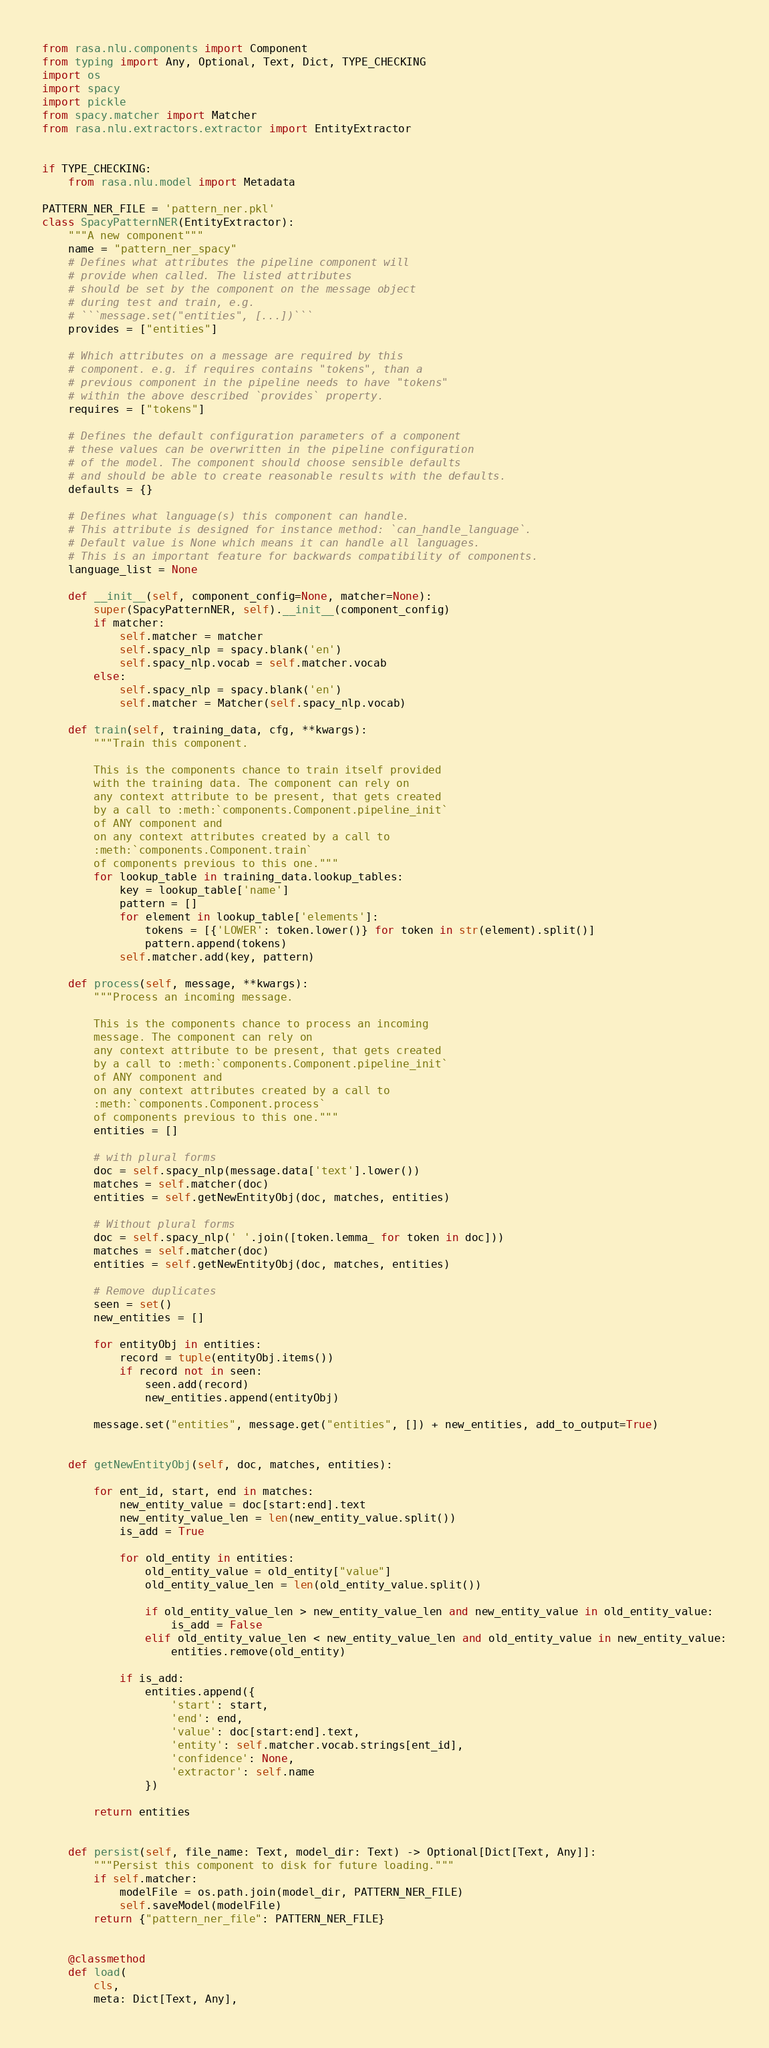<code> <loc_0><loc_0><loc_500><loc_500><_Python_>from rasa.nlu.components import Component
from typing import Any, Optional, Text, Dict, TYPE_CHECKING
import os
import spacy
import pickle
from spacy.matcher import Matcher
from rasa.nlu.extractors.extractor import EntityExtractor


if TYPE_CHECKING:
    from rasa.nlu.model import Metadata

PATTERN_NER_FILE = 'pattern_ner.pkl'
class SpacyPatternNER(EntityExtractor):
    """A new component"""
    name = "pattern_ner_spacy"
    # Defines what attributes the pipeline component will
    # provide when called. The listed attributes
    # should be set by the component on the message object
    # during test and train, e.g.
    # ```message.set("entities", [...])```
    provides = ["entities"]

    # Which attributes on a message are required by this
    # component. e.g. if requires contains "tokens", than a
    # previous component in the pipeline needs to have "tokens"
    # within the above described `provides` property.
    requires = ["tokens"]

    # Defines the default configuration parameters of a component
    # these values can be overwritten in the pipeline configuration
    # of the model. The component should choose sensible defaults
    # and should be able to create reasonable results with the defaults.
    defaults = {}

    # Defines what language(s) this component can handle.
    # This attribute is designed for instance method: `can_handle_language`.
    # Default value is None which means it can handle all languages.
    # This is an important feature for backwards compatibility of components.
    language_list = None

    def __init__(self, component_config=None, matcher=None):
        super(SpacyPatternNER, self).__init__(component_config)
        if matcher:
            self.matcher = matcher
            self.spacy_nlp = spacy.blank('en')
            self.spacy_nlp.vocab = self.matcher.vocab
        else:
            self.spacy_nlp = spacy.blank('en')
            self.matcher = Matcher(self.spacy_nlp.vocab)

    def train(self, training_data, cfg, **kwargs):
        """Train this component.

        This is the components chance to train itself provided
        with the training data. The component can rely on
        any context attribute to be present, that gets created
        by a call to :meth:`components.Component.pipeline_init`
        of ANY component and
        on any context attributes created by a call to
        :meth:`components.Component.train`
        of components previous to this one."""
        for lookup_table in training_data.lookup_tables:
            key = lookup_table['name']
            pattern = []
            for element in lookup_table['elements']:
                tokens = [{'LOWER': token.lower()} for token in str(element).split()]
                pattern.append(tokens)
            self.matcher.add(key, pattern)

    def process(self, message, **kwargs):
        """Process an incoming message.

        This is the components chance to process an incoming
        message. The component can rely on
        any context attribute to be present, that gets created
        by a call to :meth:`components.Component.pipeline_init`
        of ANY component and
        on any context attributes created by a call to
        :meth:`components.Component.process`
        of components previous to this one."""
        entities = []

        # with plural forms
        doc = self.spacy_nlp(message.data['text'].lower())
        matches = self.matcher(doc)
        entities = self.getNewEntityObj(doc, matches, entities)

        # Without plural forms
        doc = self.spacy_nlp(' '.join([token.lemma_ for token in doc]))
        matches = self.matcher(doc)
        entities = self.getNewEntityObj(doc, matches, entities)

        # Remove duplicates
        seen = set()
        new_entities = []

        for entityObj in entities:
            record = tuple(entityObj.items())
            if record not in seen:
                seen.add(record)
                new_entities.append(entityObj)

        message.set("entities", message.get("entities", []) + new_entities, add_to_output=True)


    def getNewEntityObj(self, doc, matches, entities):

        for ent_id, start, end in matches:
            new_entity_value = doc[start:end].text
            new_entity_value_len = len(new_entity_value.split())
            is_add = True

            for old_entity in entities:
                old_entity_value = old_entity["value"]
                old_entity_value_len = len(old_entity_value.split())

                if old_entity_value_len > new_entity_value_len and new_entity_value in old_entity_value:
                    is_add = False
                elif old_entity_value_len < new_entity_value_len and old_entity_value in new_entity_value:
                    entities.remove(old_entity)

            if is_add:
                entities.append({
                    'start': start,
                    'end': end,
                    'value': doc[start:end].text,
                    'entity': self.matcher.vocab.strings[ent_id],
                    'confidence': None,
                    'extractor': self.name
                })

        return entities


    def persist(self, file_name: Text, model_dir: Text) -> Optional[Dict[Text, Any]]:
        """Persist this component to disk for future loading."""
        if self.matcher:
            modelFile = os.path.join(model_dir, PATTERN_NER_FILE)
            self.saveModel(modelFile)
        return {"pattern_ner_file": PATTERN_NER_FILE}


    @classmethod
    def load(
        cls,
        meta: Dict[Text, Any],</code> 